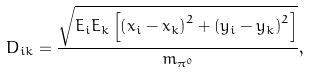<formula> <loc_0><loc_0><loc_500><loc_500>D _ { i k } = \frac { \sqrt { E _ { i } E _ { k } \left [ \left ( x _ { i } - x _ { k } \right ) ^ { 2 } + \left ( y _ { i } - y _ { k } \right ) ^ { 2 } \right ] } } { m _ { \pi ^ { 0 } } } ,</formula> 